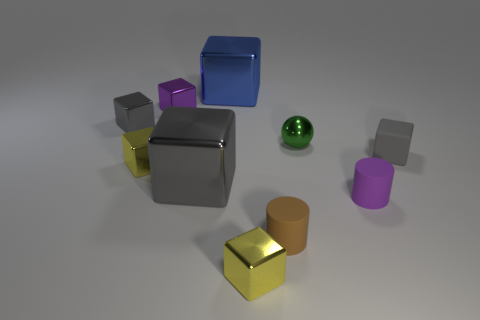Subtract all gray blocks. How many were subtracted if there are1gray blocks left? 2 Subtract all blue blocks. How many blocks are left? 6 Subtract all cyan cylinders. How many gray cubes are left? 3 Subtract all gray blocks. How many blocks are left? 4 Subtract all cylinders. How many objects are left? 8 Subtract 5 cubes. How many cubes are left? 2 Add 4 small balls. How many small balls are left? 5 Add 8 big metal cubes. How many big metal cubes exist? 10 Subtract 1 purple cubes. How many objects are left? 9 Subtract all yellow cubes. Subtract all yellow spheres. How many cubes are left? 5 